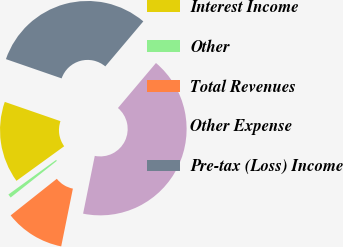Convert chart to OTSL. <chart><loc_0><loc_0><loc_500><loc_500><pie_chart><fcel>Interest Income<fcel>Other<fcel>Total Revenues<fcel>Other Expense<fcel>Pre-tax (Loss) Income<nl><fcel>15.28%<fcel>0.69%<fcel>11.15%<fcel>42.01%<fcel>30.86%<nl></chart> 